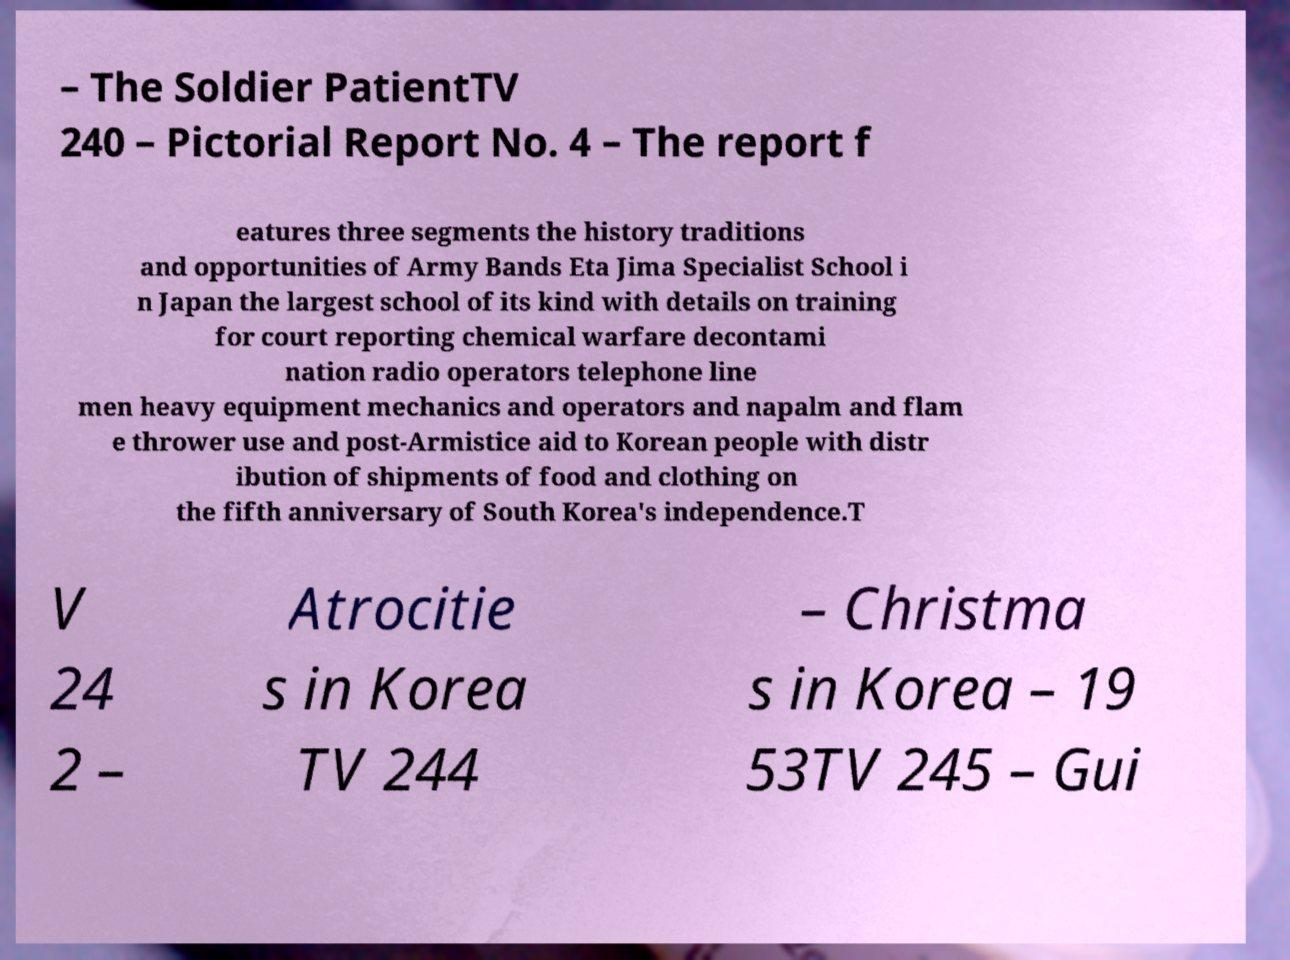There's text embedded in this image that I need extracted. Can you transcribe it verbatim? – The Soldier PatientTV 240 – Pictorial Report No. 4 – The report f eatures three segments the history traditions and opportunities of Army Bands Eta Jima Specialist School i n Japan the largest school of its kind with details on training for court reporting chemical warfare decontami nation radio operators telephone line men heavy equipment mechanics and operators and napalm and flam e thrower use and post-Armistice aid to Korean people with distr ibution of shipments of food and clothing on the fifth anniversary of South Korea's independence.T V 24 2 – Atrocitie s in Korea TV 244 – Christma s in Korea – 19 53TV 245 – Gui 